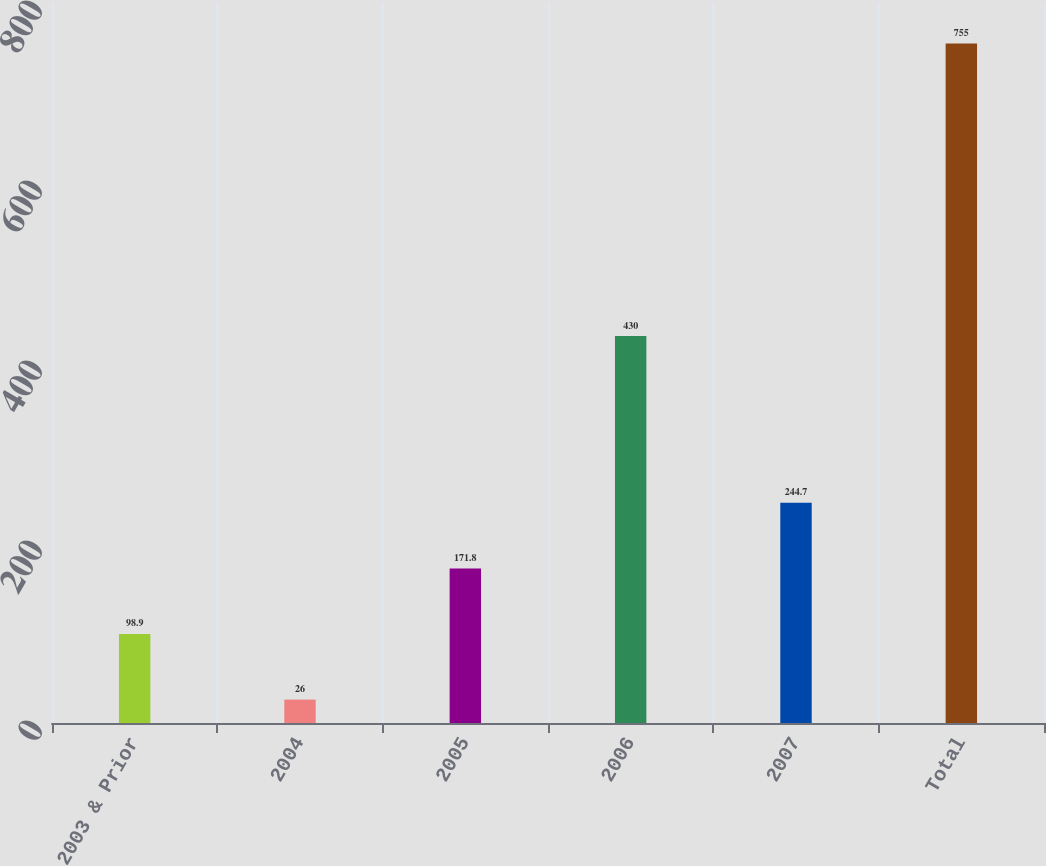Convert chart to OTSL. <chart><loc_0><loc_0><loc_500><loc_500><bar_chart><fcel>2003 & Prior<fcel>2004<fcel>2005<fcel>2006<fcel>2007<fcel>Total<nl><fcel>98.9<fcel>26<fcel>171.8<fcel>430<fcel>244.7<fcel>755<nl></chart> 